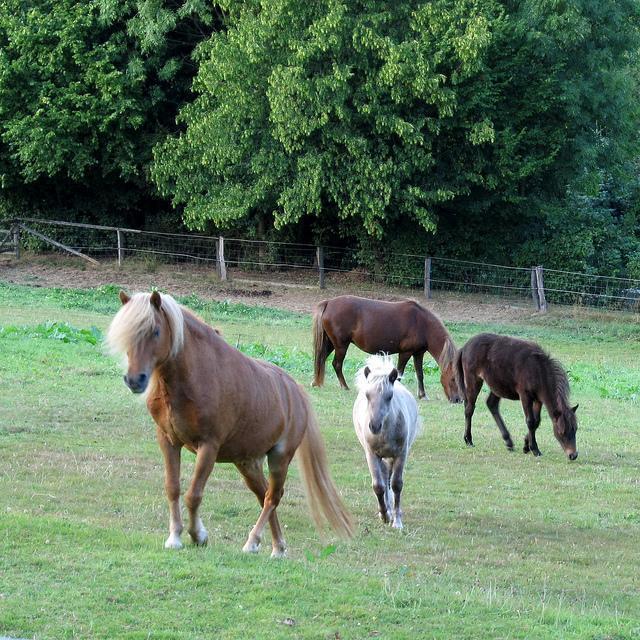What animals are present?
Indicate the correct response by choosing from the four available options to answer the question.
Options: Goat, sheep, cow, horse. Horse. 